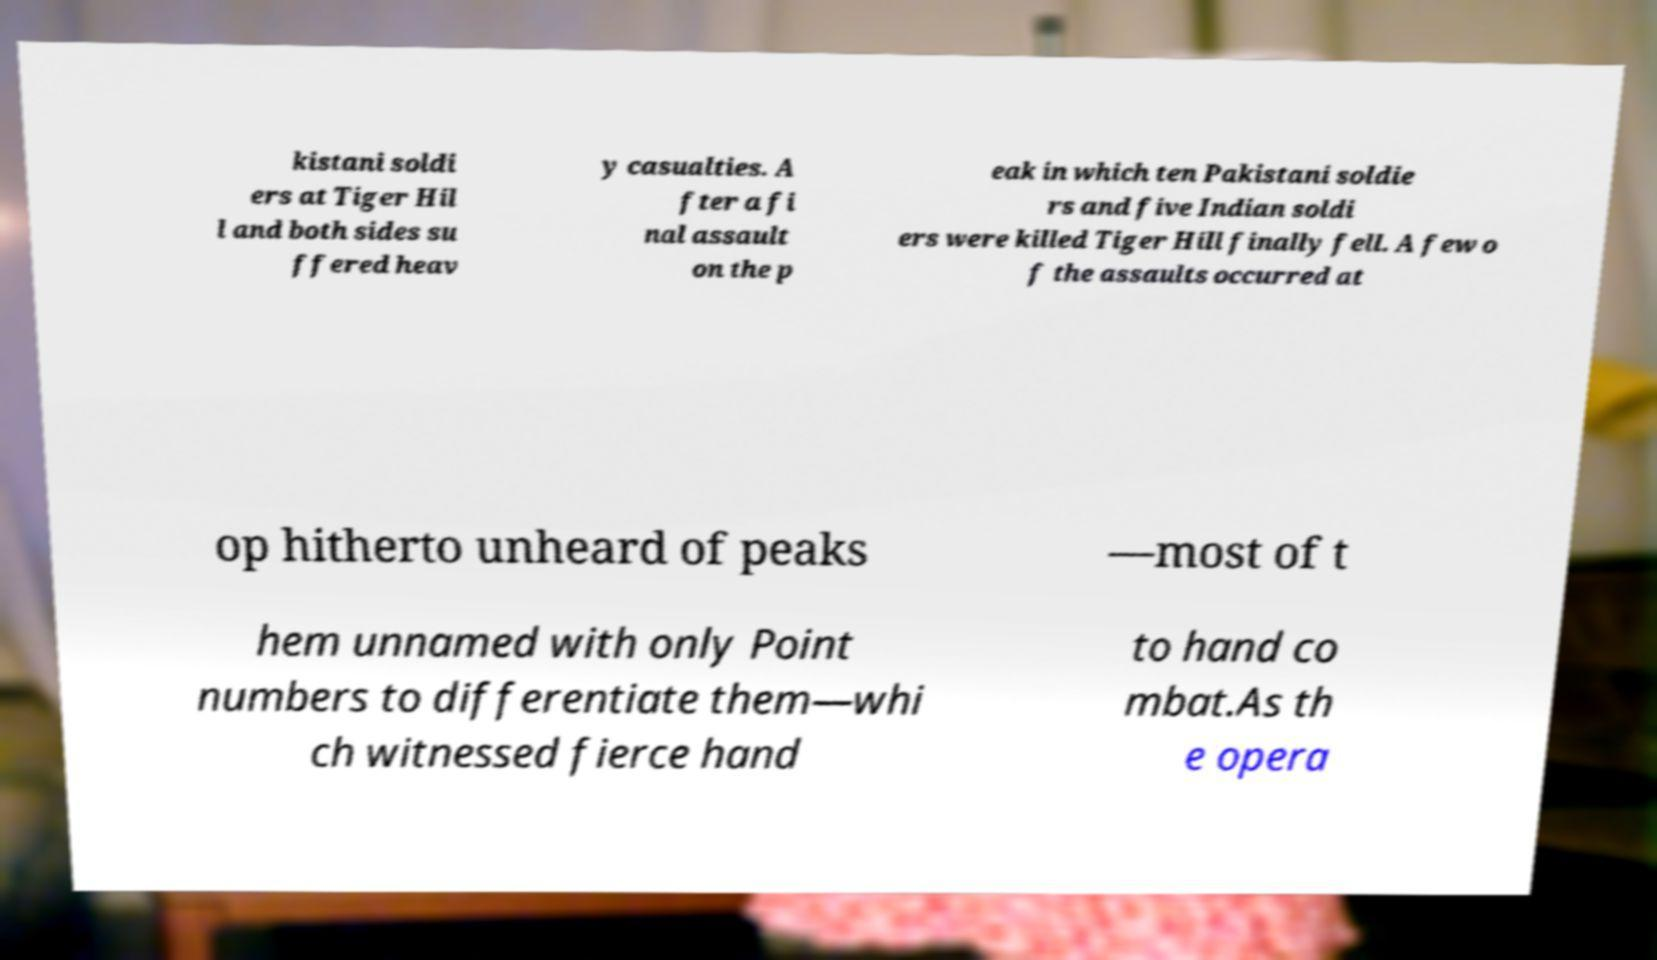Could you assist in decoding the text presented in this image and type it out clearly? kistani soldi ers at Tiger Hil l and both sides su ffered heav y casualties. A fter a fi nal assault on the p eak in which ten Pakistani soldie rs and five Indian soldi ers were killed Tiger Hill finally fell. A few o f the assaults occurred at op hitherto unheard of peaks —most of t hem unnamed with only Point numbers to differentiate them—whi ch witnessed fierce hand to hand co mbat.As th e opera 